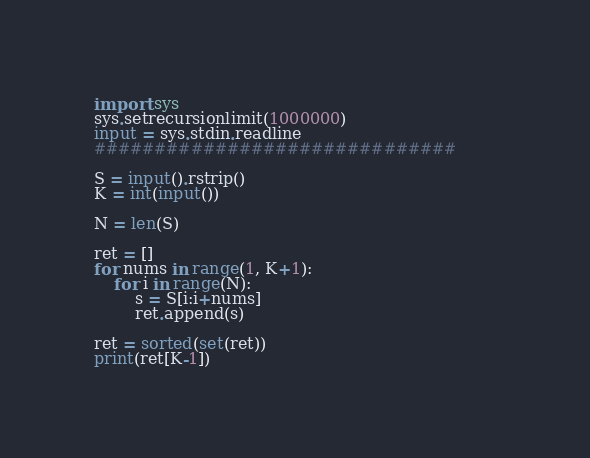Convert code to text. <code><loc_0><loc_0><loc_500><loc_500><_Python_>
import sys
sys.setrecursionlimit(1000000)
input = sys.stdin.readline
##############################

S = input().rstrip()
K = int(input())

N = len(S)

ret = []
for nums in range(1, K+1):
    for i in range(N):
        s = S[i:i+nums]
        ret.append(s)

ret = sorted(set(ret))
print(ret[K-1])
</code> 